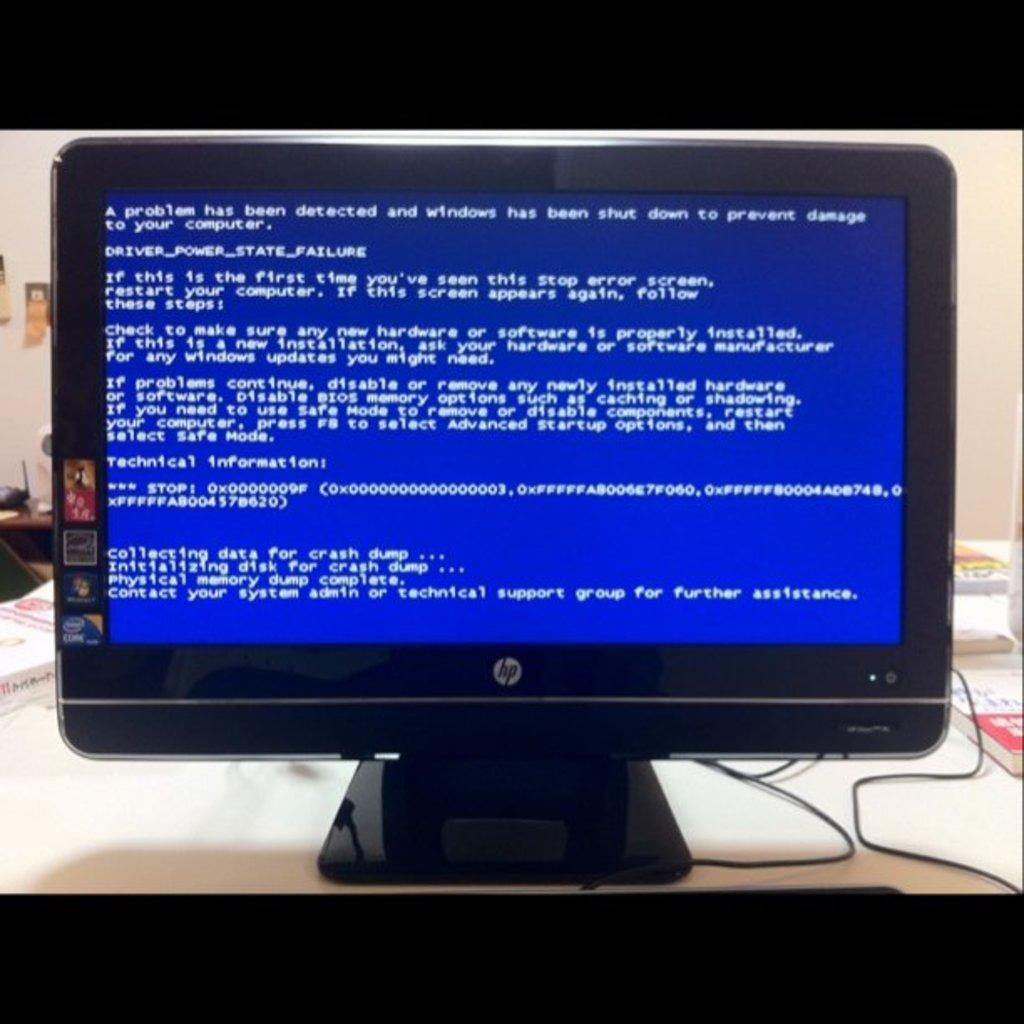What objects are on the table in the image? There are books and a monitor with a screen on the table. Can you describe the monitor in the image? The monitor has a screen, which suggests it is an electronic device for displaying information. What type of quilt is draped over the sofa in the image? There is no sofa or quilt present in the image; the image only features a table with books and a monitor. 